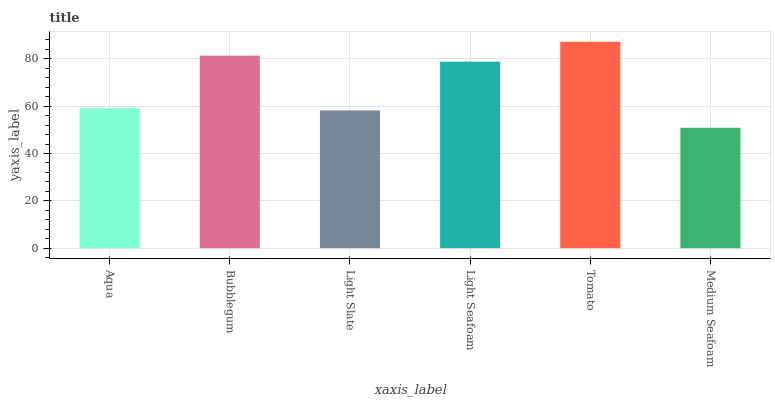Is Medium Seafoam the minimum?
Answer yes or no. Yes. Is Tomato the maximum?
Answer yes or no. Yes. Is Bubblegum the minimum?
Answer yes or no. No. Is Bubblegum the maximum?
Answer yes or no. No. Is Bubblegum greater than Aqua?
Answer yes or no. Yes. Is Aqua less than Bubblegum?
Answer yes or no. Yes. Is Aqua greater than Bubblegum?
Answer yes or no. No. Is Bubblegum less than Aqua?
Answer yes or no. No. Is Light Seafoam the high median?
Answer yes or no. Yes. Is Aqua the low median?
Answer yes or no. Yes. Is Tomato the high median?
Answer yes or no. No. Is Light Seafoam the low median?
Answer yes or no. No. 